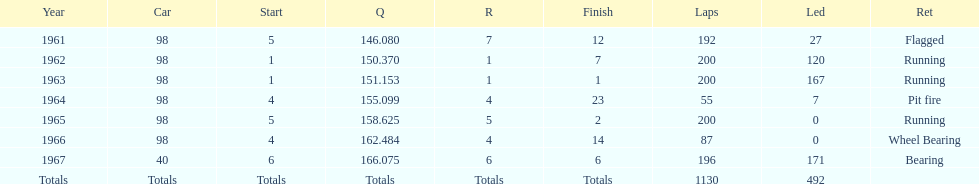What is the most common cause for a retired car? Running. 